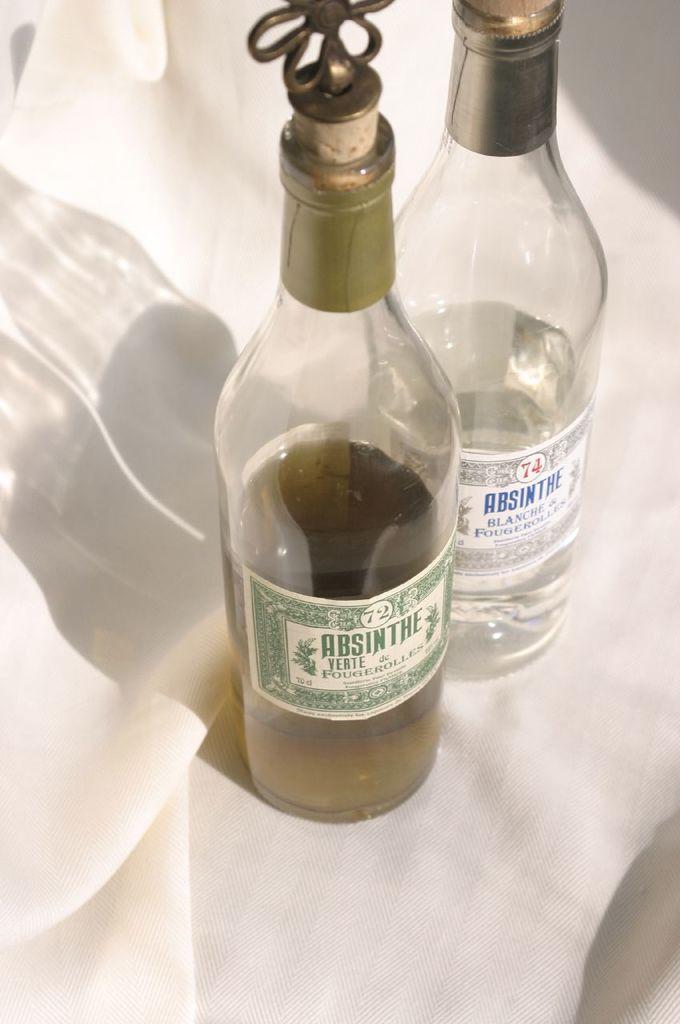Describe this image in one or two sentences. In this image I can see there are two glass bottles and a white cloth. 